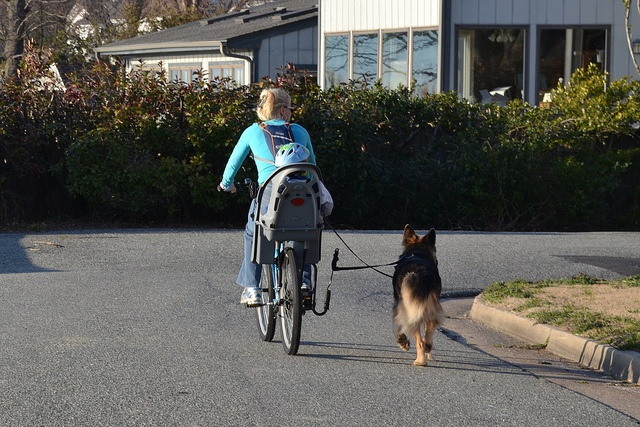Describe the objects in this image and their specific colors. I can see bicycle in black, gray, darkgray, and lightgray tones, dog in black, gray, and maroon tones, people in black, cyan, gray, and darkgray tones, backpack in black, navy, gray, and darkblue tones, and people in black, gray, and white tones in this image. 